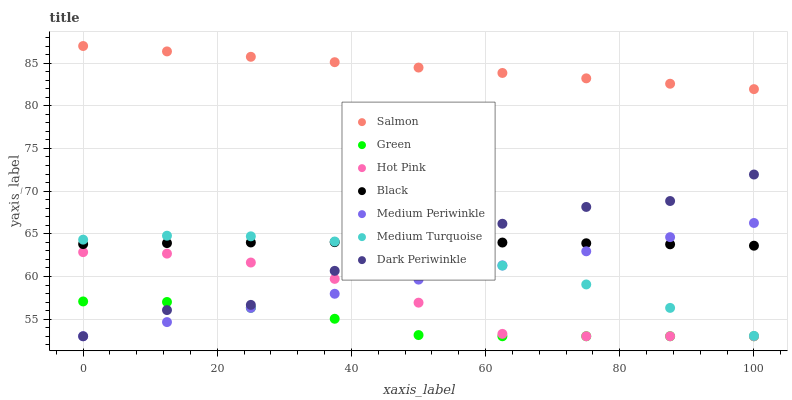Does Green have the minimum area under the curve?
Answer yes or no. Yes. Does Salmon have the maximum area under the curve?
Answer yes or no. Yes. Does Hot Pink have the minimum area under the curve?
Answer yes or no. No. Does Hot Pink have the maximum area under the curve?
Answer yes or no. No. Is Medium Periwinkle the smoothest?
Answer yes or no. Yes. Is Dark Periwinkle the roughest?
Answer yes or no. Yes. Is Hot Pink the smoothest?
Answer yes or no. No. Is Hot Pink the roughest?
Answer yes or no. No. Does Medium Periwinkle have the lowest value?
Answer yes or no. Yes. Does Salmon have the lowest value?
Answer yes or no. No. Does Salmon have the highest value?
Answer yes or no. Yes. Does Hot Pink have the highest value?
Answer yes or no. No. Is Black less than Salmon?
Answer yes or no. Yes. Is Black greater than Hot Pink?
Answer yes or no. Yes. Does Hot Pink intersect Medium Periwinkle?
Answer yes or no. Yes. Is Hot Pink less than Medium Periwinkle?
Answer yes or no. No. Is Hot Pink greater than Medium Periwinkle?
Answer yes or no. No. Does Black intersect Salmon?
Answer yes or no. No. 